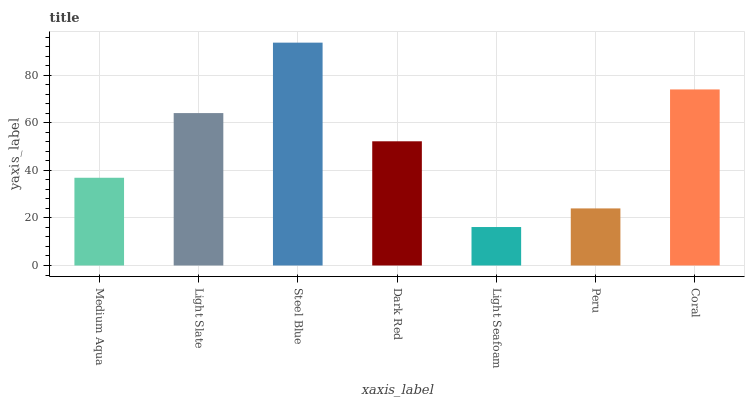Is Light Seafoam the minimum?
Answer yes or no. Yes. Is Steel Blue the maximum?
Answer yes or no. Yes. Is Light Slate the minimum?
Answer yes or no. No. Is Light Slate the maximum?
Answer yes or no. No. Is Light Slate greater than Medium Aqua?
Answer yes or no. Yes. Is Medium Aqua less than Light Slate?
Answer yes or no. Yes. Is Medium Aqua greater than Light Slate?
Answer yes or no. No. Is Light Slate less than Medium Aqua?
Answer yes or no. No. Is Dark Red the high median?
Answer yes or no. Yes. Is Dark Red the low median?
Answer yes or no. Yes. Is Steel Blue the high median?
Answer yes or no. No. Is Steel Blue the low median?
Answer yes or no. No. 